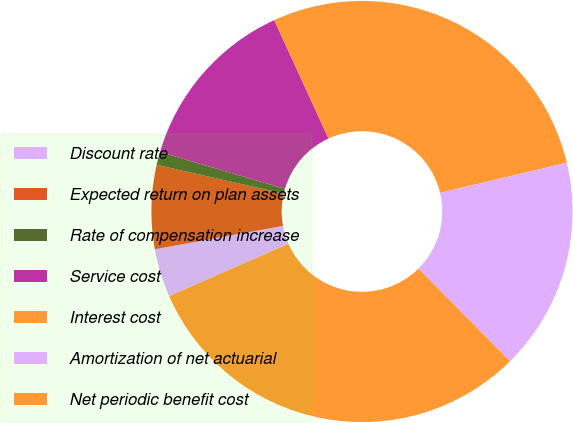Convert chart. <chart><loc_0><loc_0><loc_500><loc_500><pie_chart><fcel>Discount rate<fcel>Expected return on plan assets<fcel>Rate of compensation increase<fcel>Service cost<fcel>Interest cost<fcel>Amortization of net actuarial<fcel>Net periodic benefit cost<nl><fcel>3.72%<fcel>6.43%<fcel>1.0%<fcel>13.6%<fcel>28.12%<fcel>16.31%<fcel>30.83%<nl></chart> 